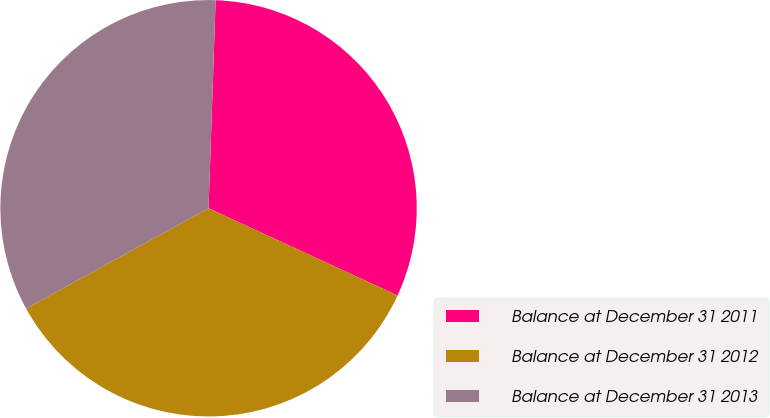Convert chart to OTSL. <chart><loc_0><loc_0><loc_500><loc_500><pie_chart><fcel>Balance at December 31 2011<fcel>Balance at December 31 2012<fcel>Balance at December 31 2013<nl><fcel>31.34%<fcel>35.12%<fcel>33.54%<nl></chart> 